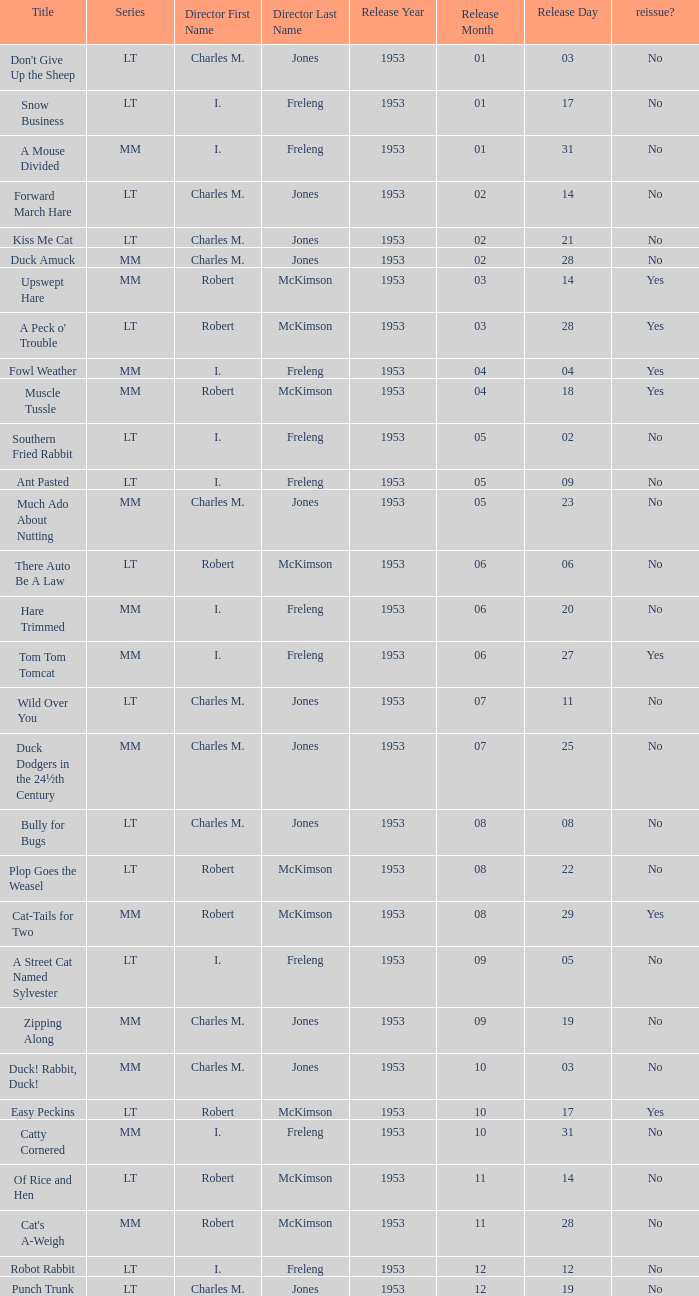What's the series of Kiss Me Cat? LT. 